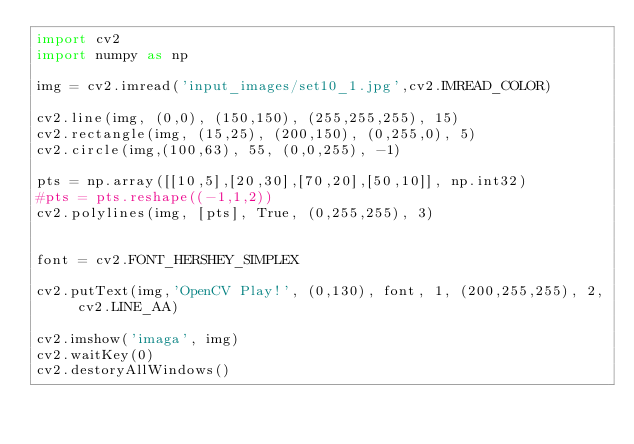<code> <loc_0><loc_0><loc_500><loc_500><_Python_>import cv2
import numpy as np

img = cv2.imread('input_images/set10_1.jpg',cv2.IMREAD_COLOR)

cv2.line(img, (0,0), (150,150), (255,255,255), 15)
cv2.rectangle(img, (15,25), (200,150), (0,255,0), 5)
cv2.circle(img,(100,63), 55, (0,0,255), -1)

pts = np.array([[10,5],[20,30],[70,20],[50,10]], np.int32)
#pts = pts.reshape((-1,1,2))
cv2.polylines(img, [pts], True, (0,255,255), 3)


font = cv2.FONT_HERSHEY_SIMPLEX

cv2.putText(img,'OpenCV Play!', (0,130), font, 1, (200,255,255), 2, cv2.LINE_AA)

cv2.imshow('imaga', img)
cv2.waitKey(0)
cv2.destoryAllWindows()
</code> 